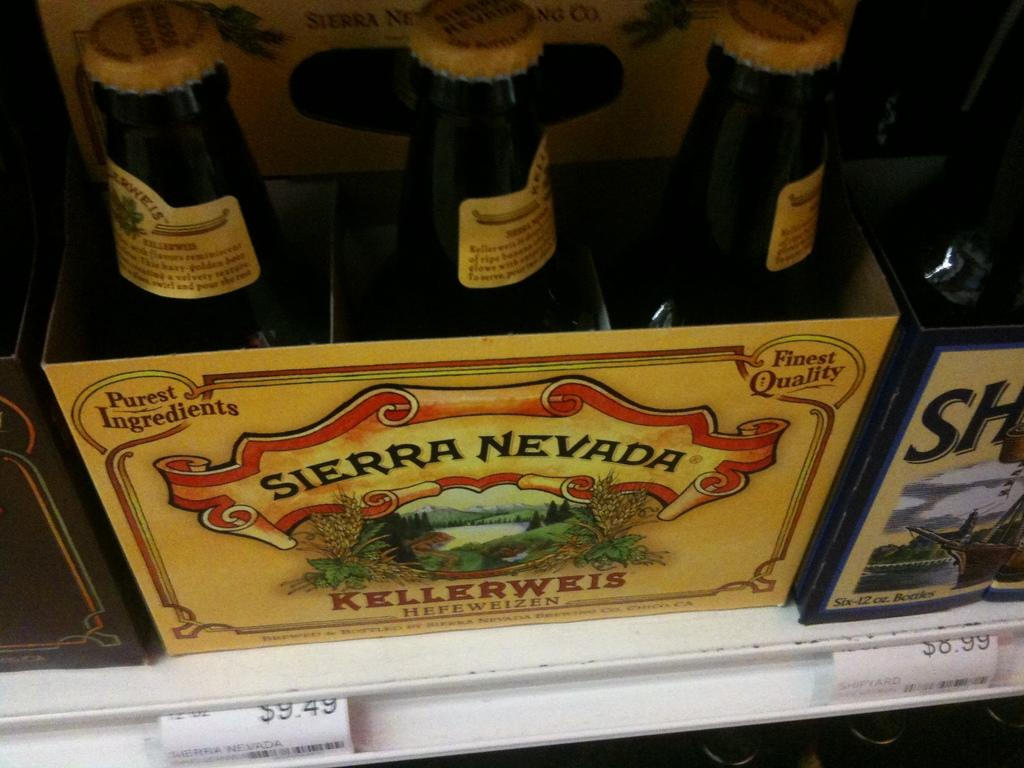<image>
Give a short and clear explanation of the subsequent image. A six pack of Sierra Nevada brand Keelerweis bottles of beer with tan labels. 